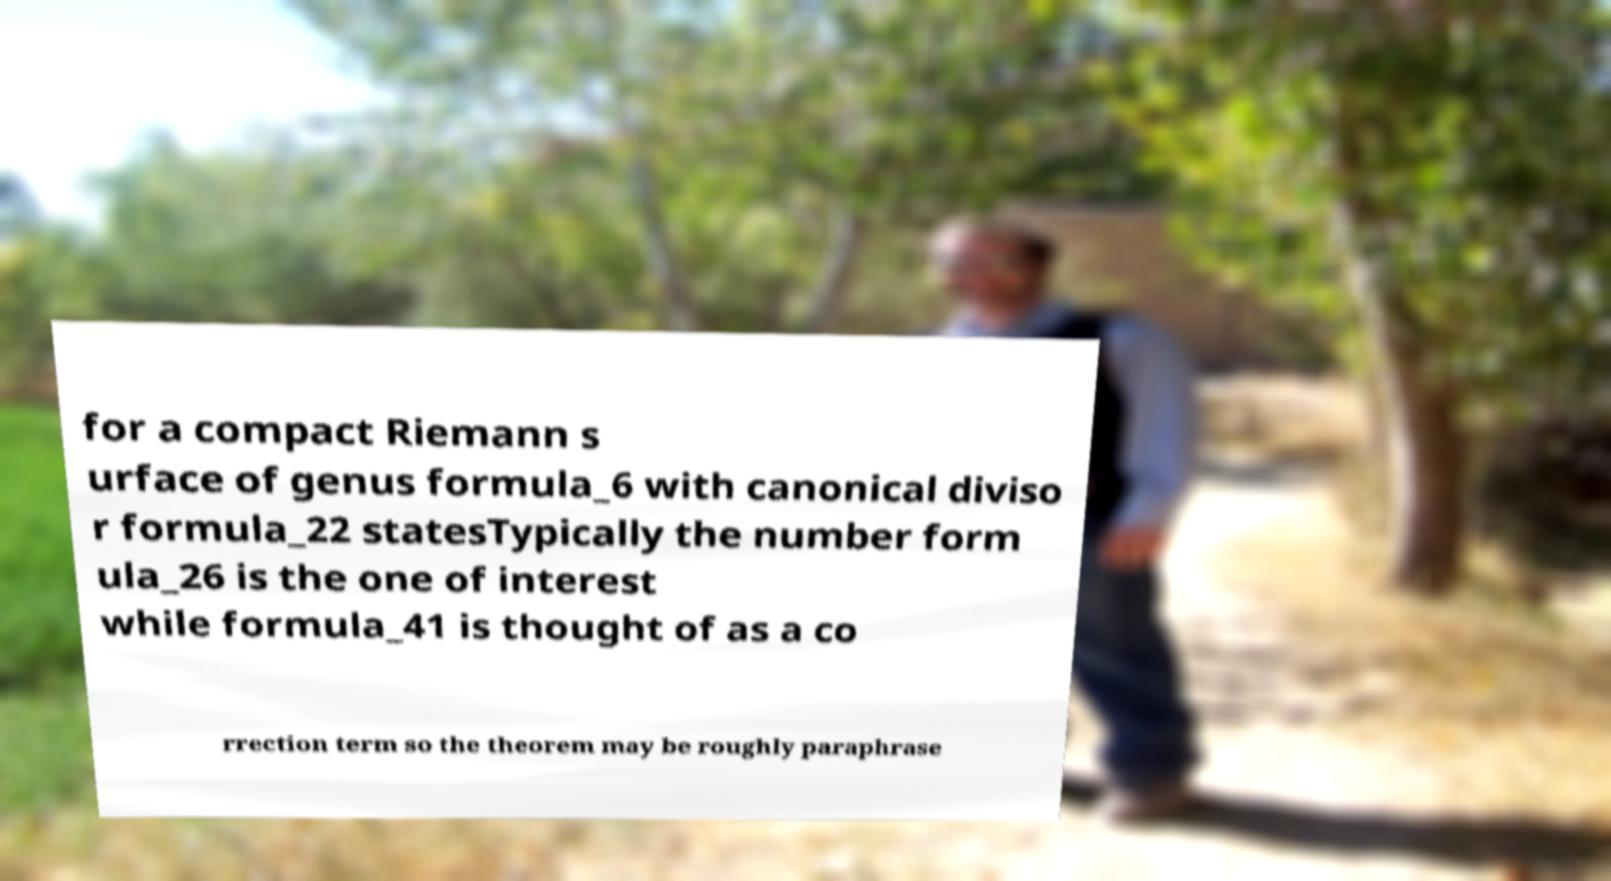I need the written content from this picture converted into text. Can you do that? for a compact Riemann s urface of genus formula_6 with canonical diviso r formula_22 statesTypically the number form ula_26 is the one of interest while formula_41 is thought of as a co rrection term so the theorem may be roughly paraphrase 